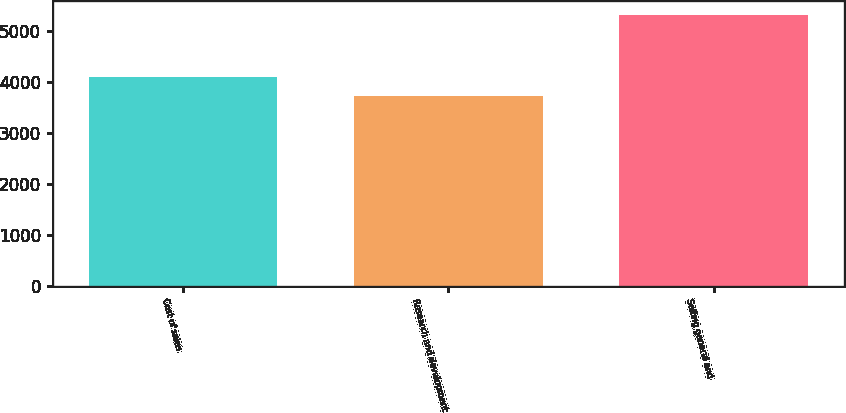<chart> <loc_0><loc_0><loc_500><loc_500><bar_chart><fcel>Cost of sales<fcel>Research and development<fcel>Selling general and<nl><fcel>4101<fcel>3737<fcel>5332<nl></chart> 